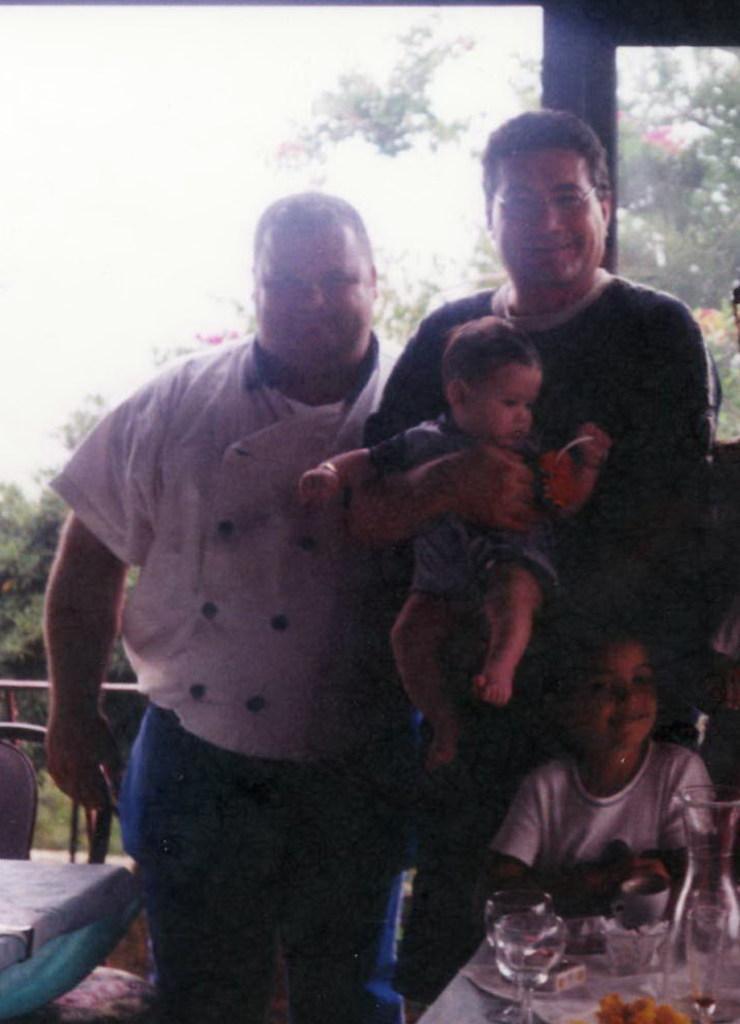Please provide a concise description of this image. There are two men standing and smiling. This man is holding a boy in his hands. Here is another kid standing. This looks like a table with wine glasses, far and few other things. This looks like a door. These are the trees. This looks like a chair. 